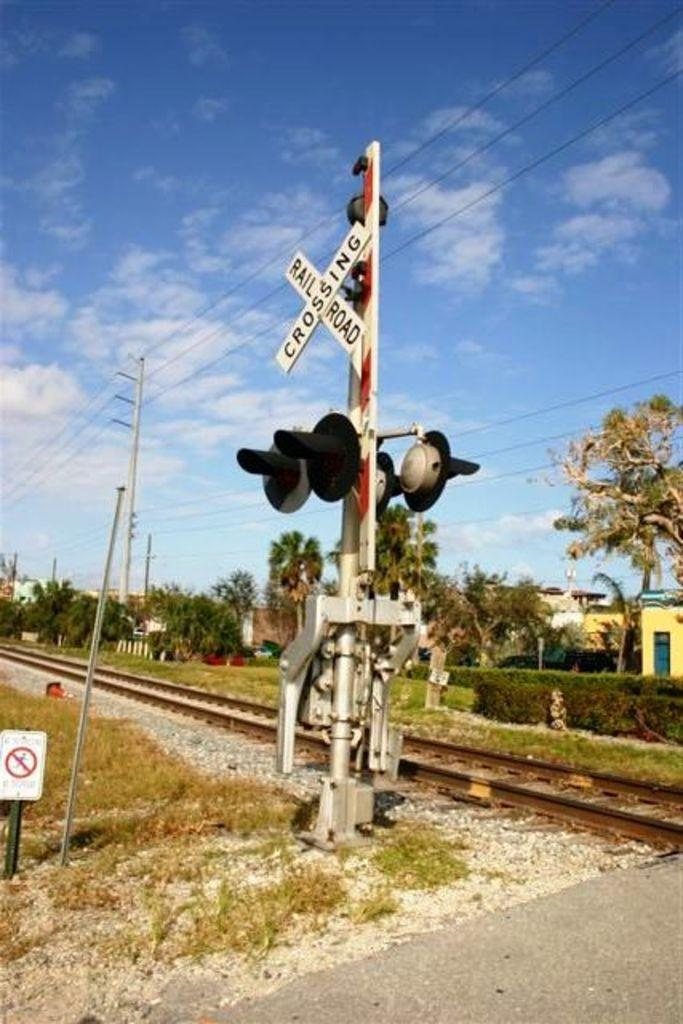<image>
Present a compact description of the photo's key features. A railroad track with the railroad crossing sign and bar lifted out of the way of traveling cars. 